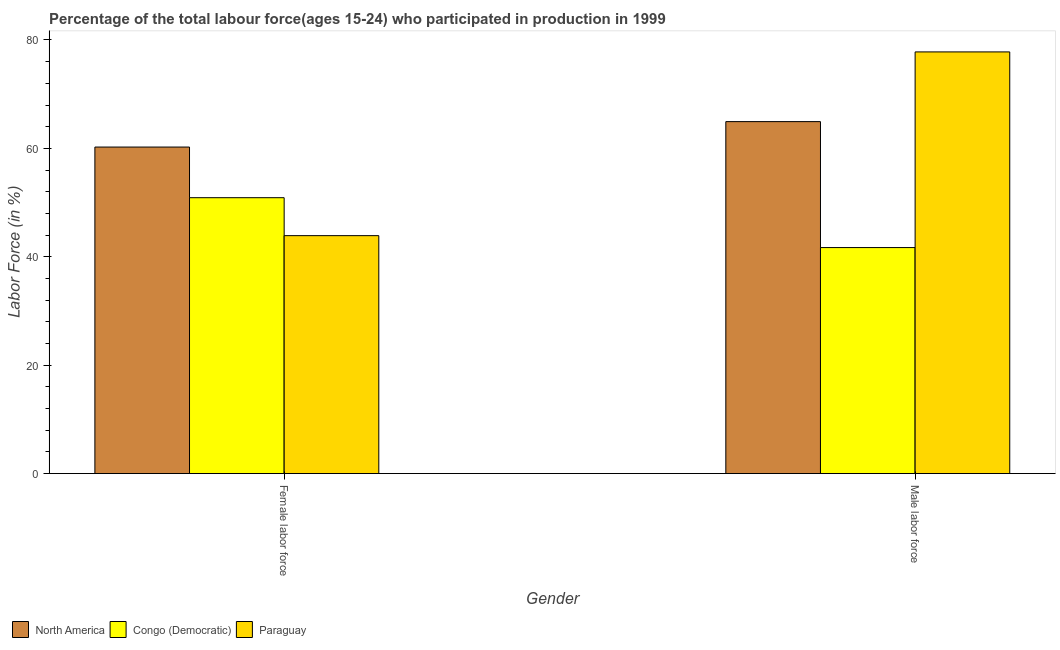How many different coloured bars are there?
Ensure brevity in your answer.  3. How many groups of bars are there?
Offer a terse response. 2. Are the number of bars per tick equal to the number of legend labels?
Offer a very short reply. Yes. How many bars are there on the 2nd tick from the left?
Your answer should be compact. 3. What is the label of the 2nd group of bars from the left?
Offer a very short reply. Male labor force. What is the percentage of male labour force in Paraguay?
Your response must be concise. 77.8. Across all countries, what is the maximum percentage of male labour force?
Give a very brief answer. 77.8. Across all countries, what is the minimum percentage of male labour force?
Make the answer very short. 41.7. In which country was the percentage of male labour force maximum?
Your answer should be compact. Paraguay. In which country was the percentage of male labour force minimum?
Your answer should be compact. Congo (Democratic). What is the total percentage of female labor force in the graph?
Make the answer very short. 155.04. What is the difference between the percentage of male labour force in North America and that in Congo (Democratic)?
Offer a terse response. 23.24. What is the difference between the percentage of female labor force in Paraguay and the percentage of male labour force in Congo (Democratic)?
Offer a very short reply. 2.2. What is the average percentage of female labor force per country?
Keep it short and to the point. 51.68. What is the difference between the percentage of female labor force and percentage of male labour force in North America?
Your answer should be compact. -4.69. In how many countries, is the percentage of female labor force greater than 32 %?
Your answer should be compact. 3. What is the ratio of the percentage of male labour force in North America to that in Congo (Democratic)?
Your response must be concise. 1.56. Is the percentage of female labor force in North America less than that in Paraguay?
Offer a terse response. No. What does the 3rd bar from the left in Male labor force represents?
Your answer should be very brief. Paraguay. What does the 1st bar from the right in Male labor force represents?
Give a very brief answer. Paraguay. How many bars are there?
Provide a succinct answer. 6. Are all the bars in the graph horizontal?
Keep it short and to the point. No. What is the difference between two consecutive major ticks on the Y-axis?
Keep it short and to the point. 20. Does the graph contain any zero values?
Provide a succinct answer. No. Does the graph contain grids?
Make the answer very short. No. Where does the legend appear in the graph?
Give a very brief answer. Bottom left. What is the title of the graph?
Give a very brief answer. Percentage of the total labour force(ages 15-24) who participated in production in 1999. Does "Hong Kong" appear as one of the legend labels in the graph?
Give a very brief answer. No. What is the Labor Force (in %) of North America in Female labor force?
Offer a very short reply. 60.24. What is the Labor Force (in %) in Congo (Democratic) in Female labor force?
Your response must be concise. 50.9. What is the Labor Force (in %) in Paraguay in Female labor force?
Offer a terse response. 43.9. What is the Labor Force (in %) of North America in Male labor force?
Provide a short and direct response. 64.94. What is the Labor Force (in %) in Congo (Democratic) in Male labor force?
Offer a terse response. 41.7. What is the Labor Force (in %) of Paraguay in Male labor force?
Provide a succinct answer. 77.8. Across all Gender, what is the maximum Labor Force (in %) in North America?
Your answer should be compact. 64.94. Across all Gender, what is the maximum Labor Force (in %) of Congo (Democratic)?
Provide a short and direct response. 50.9. Across all Gender, what is the maximum Labor Force (in %) of Paraguay?
Your response must be concise. 77.8. Across all Gender, what is the minimum Labor Force (in %) of North America?
Your answer should be compact. 60.24. Across all Gender, what is the minimum Labor Force (in %) of Congo (Democratic)?
Provide a succinct answer. 41.7. Across all Gender, what is the minimum Labor Force (in %) in Paraguay?
Keep it short and to the point. 43.9. What is the total Labor Force (in %) of North America in the graph?
Offer a terse response. 125.18. What is the total Labor Force (in %) in Congo (Democratic) in the graph?
Provide a succinct answer. 92.6. What is the total Labor Force (in %) of Paraguay in the graph?
Give a very brief answer. 121.7. What is the difference between the Labor Force (in %) of North America in Female labor force and that in Male labor force?
Provide a succinct answer. -4.69. What is the difference between the Labor Force (in %) in Paraguay in Female labor force and that in Male labor force?
Your response must be concise. -33.9. What is the difference between the Labor Force (in %) of North America in Female labor force and the Labor Force (in %) of Congo (Democratic) in Male labor force?
Make the answer very short. 18.54. What is the difference between the Labor Force (in %) in North America in Female labor force and the Labor Force (in %) in Paraguay in Male labor force?
Provide a short and direct response. -17.56. What is the difference between the Labor Force (in %) in Congo (Democratic) in Female labor force and the Labor Force (in %) in Paraguay in Male labor force?
Your answer should be compact. -26.9. What is the average Labor Force (in %) of North America per Gender?
Offer a terse response. 62.59. What is the average Labor Force (in %) in Congo (Democratic) per Gender?
Keep it short and to the point. 46.3. What is the average Labor Force (in %) in Paraguay per Gender?
Make the answer very short. 60.85. What is the difference between the Labor Force (in %) in North America and Labor Force (in %) in Congo (Democratic) in Female labor force?
Ensure brevity in your answer.  9.34. What is the difference between the Labor Force (in %) of North America and Labor Force (in %) of Paraguay in Female labor force?
Keep it short and to the point. 16.34. What is the difference between the Labor Force (in %) of North America and Labor Force (in %) of Congo (Democratic) in Male labor force?
Keep it short and to the point. 23.24. What is the difference between the Labor Force (in %) in North America and Labor Force (in %) in Paraguay in Male labor force?
Make the answer very short. -12.86. What is the difference between the Labor Force (in %) in Congo (Democratic) and Labor Force (in %) in Paraguay in Male labor force?
Provide a succinct answer. -36.1. What is the ratio of the Labor Force (in %) in North America in Female labor force to that in Male labor force?
Your answer should be very brief. 0.93. What is the ratio of the Labor Force (in %) of Congo (Democratic) in Female labor force to that in Male labor force?
Your answer should be very brief. 1.22. What is the ratio of the Labor Force (in %) in Paraguay in Female labor force to that in Male labor force?
Provide a succinct answer. 0.56. What is the difference between the highest and the second highest Labor Force (in %) of North America?
Your answer should be compact. 4.69. What is the difference between the highest and the second highest Labor Force (in %) in Paraguay?
Ensure brevity in your answer.  33.9. What is the difference between the highest and the lowest Labor Force (in %) in North America?
Ensure brevity in your answer.  4.69. What is the difference between the highest and the lowest Labor Force (in %) in Paraguay?
Your answer should be compact. 33.9. 